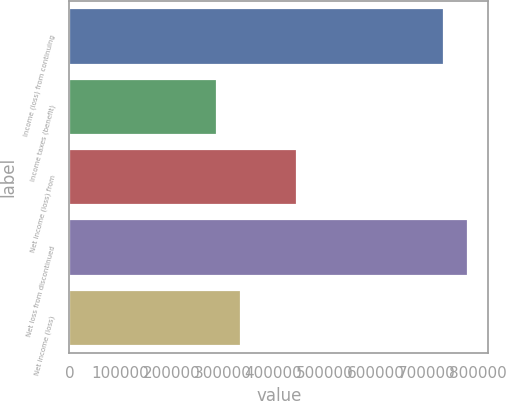<chart> <loc_0><loc_0><loc_500><loc_500><bar_chart><fcel>Income (loss) from continuing<fcel>Income taxes (benefit)<fcel>Net income (loss) from<fcel>Net loss from discontinued<fcel>Net income (loss)<nl><fcel>735071<fcel>289124<fcel>445947<fcel>781618<fcel>335671<nl></chart> 